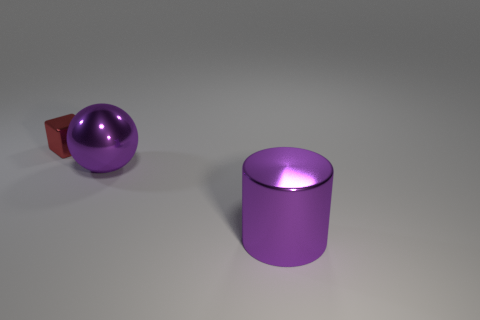What number of other objects are the same size as the sphere?
Make the answer very short. 1. The large purple metal object left of the big purple thing in front of the ball is what shape?
Provide a succinct answer. Sphere. There is a big metal object that is in front of the sphere; is its color the same as the large shiny thing on the left side of the large purple shiny cylinder?
Provide a short and direct response. Yes. Are there any other things of the same color as the metallic sphere?
Give a very brief answer. Yes. The shiny cylinder is what color?
Your answer should be compact. Purple. Are there any red metal cubes?
Provide a short and direct response. Yes. Are there any large cylinders to the left of the tiny cube?
Keep it short and to the point. No. Is there any other thing that has the same material as the small block?
Keep it short and to the point. Yes. What number of other things are there of the same shape as the small red thing?
Provide a short and direct response. 0. There is a object to the right of the big object to the left of the cylinder; how many spheres are on the left side of it?
Your answer should be very brief. 1. 